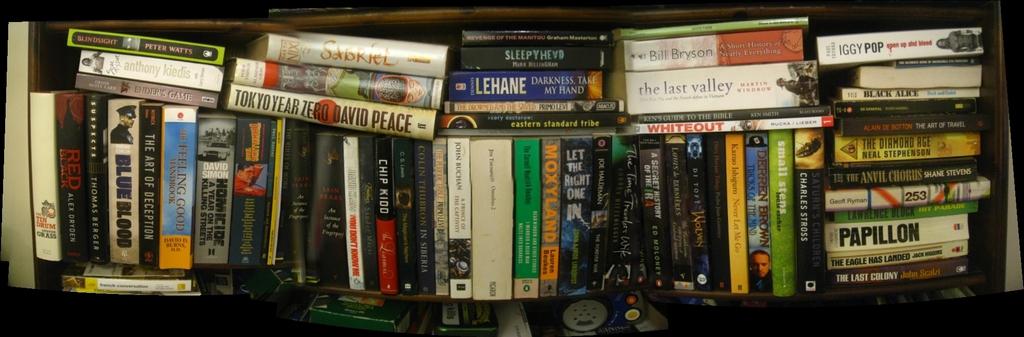What is the title of one of these books?
Ensure brevity in your answer.  Tokyo year zero. What is the title of the book by david peace?
Your response must be concise. Tokyo year zero. 